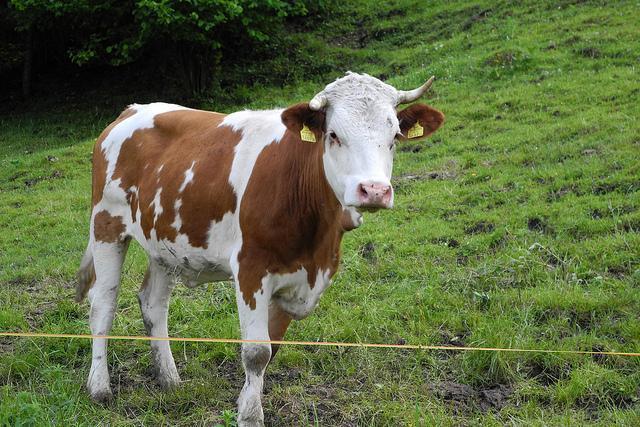How many cows are there?
Give a very brief answer. 1. How many people have a shaved head?
Give a very brief answer. 0. 